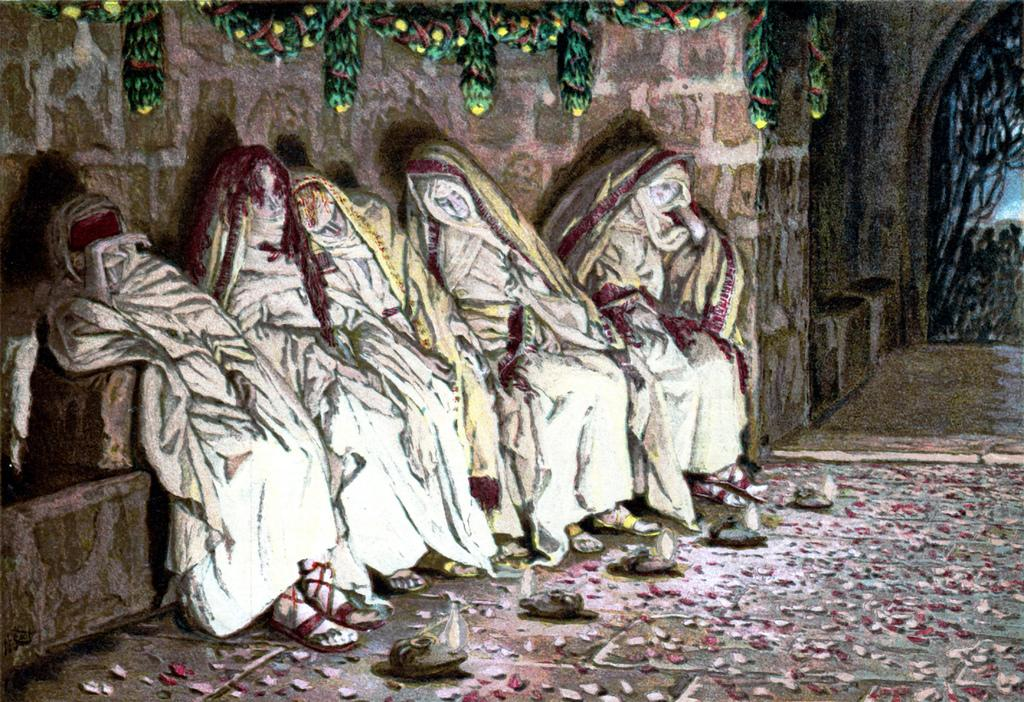What type of artwork is depicted in the image? The image appears to be a painting. What subjects are featured in the painting? There are multiple statues in the image. What can be seen at the bottom of the painting? There are lights at the bottom of the image. What type of volleyball game is being played in the image? There is no volleyball game present in the image; it features a painting with multiple statues and lights. What type of chain is used to secure the statues in the image? There is no chain visible in the image; it features a painting with multiple statues and lights. 